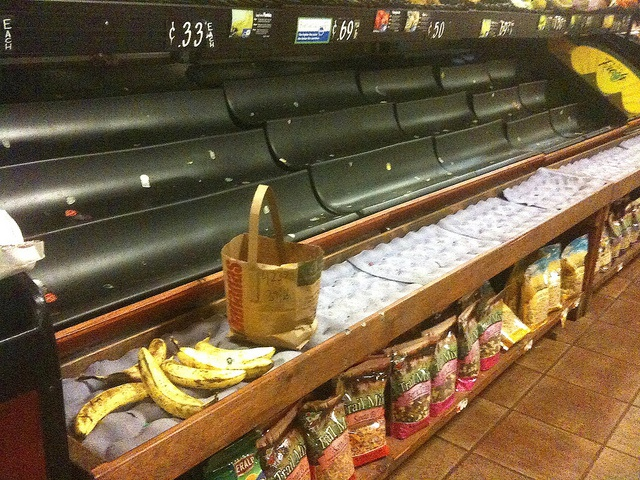Describe the objects in this image and their specific colors. I can see a banana in black, khaki, beige, and olive tones in this image. 